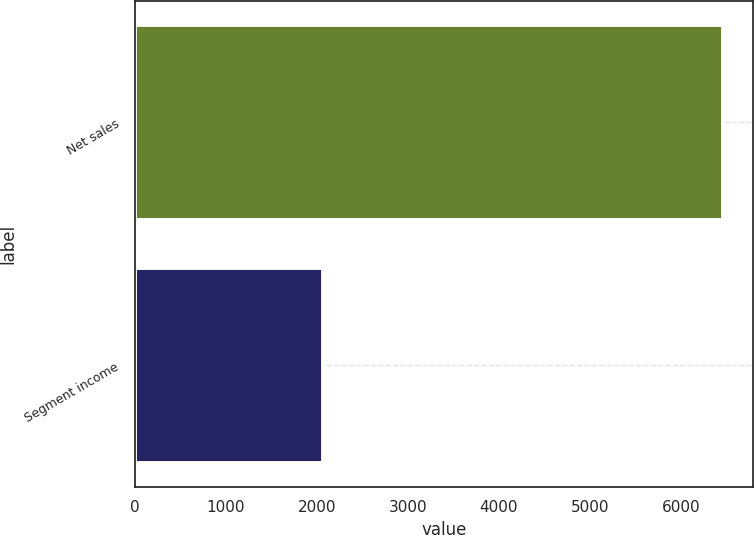<chart> <loc_0><loc_0><loc_500><loc_500><bar_chart><fcel>Net sales<fcel>Segment income<nl><fcel>6468.1<fcel>2074<nl></chart> 